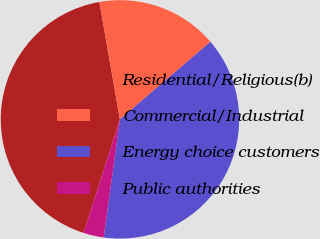Convert chart. <chart><loc_0><loc_0><loc_500><loc_500><pie_chart><fcel>Residential/Religious(b)<fcel>Commercial/Industrial<fcel>Energy choice customers<fcel>Public authorities<nl><fcel>42.31%<fcel>16.48%<fcel>38.46%<fcel>2.75%<nl></chart> 